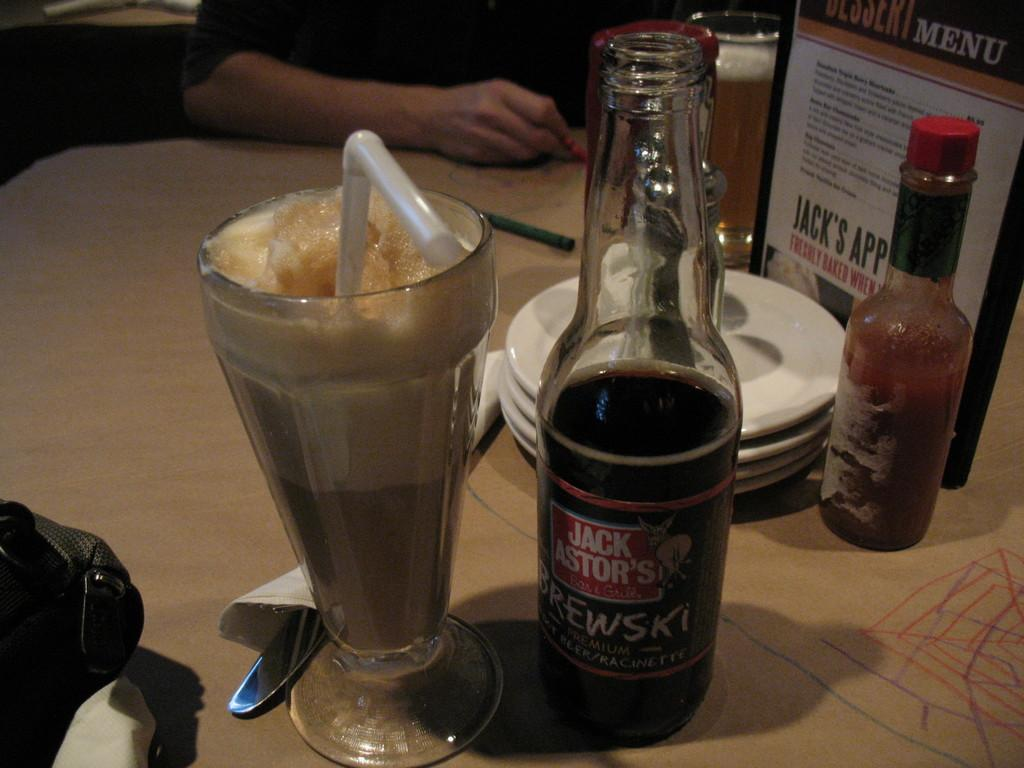Provide a one-sentence caption for the provided image. a JACK ASTOR'S BREWSKI half empty beer bottle with a root beer float and tobasco sauce bottle next to it. 